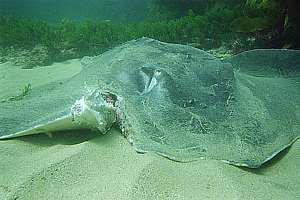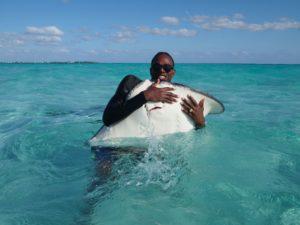The first image is the image on the left, the second image is the image on the right. Considering the images on both sides, is "In one image there is a lone ray at the bottom of the ocean that has buried itself in the sand." valid? Answer yes or no. No. 